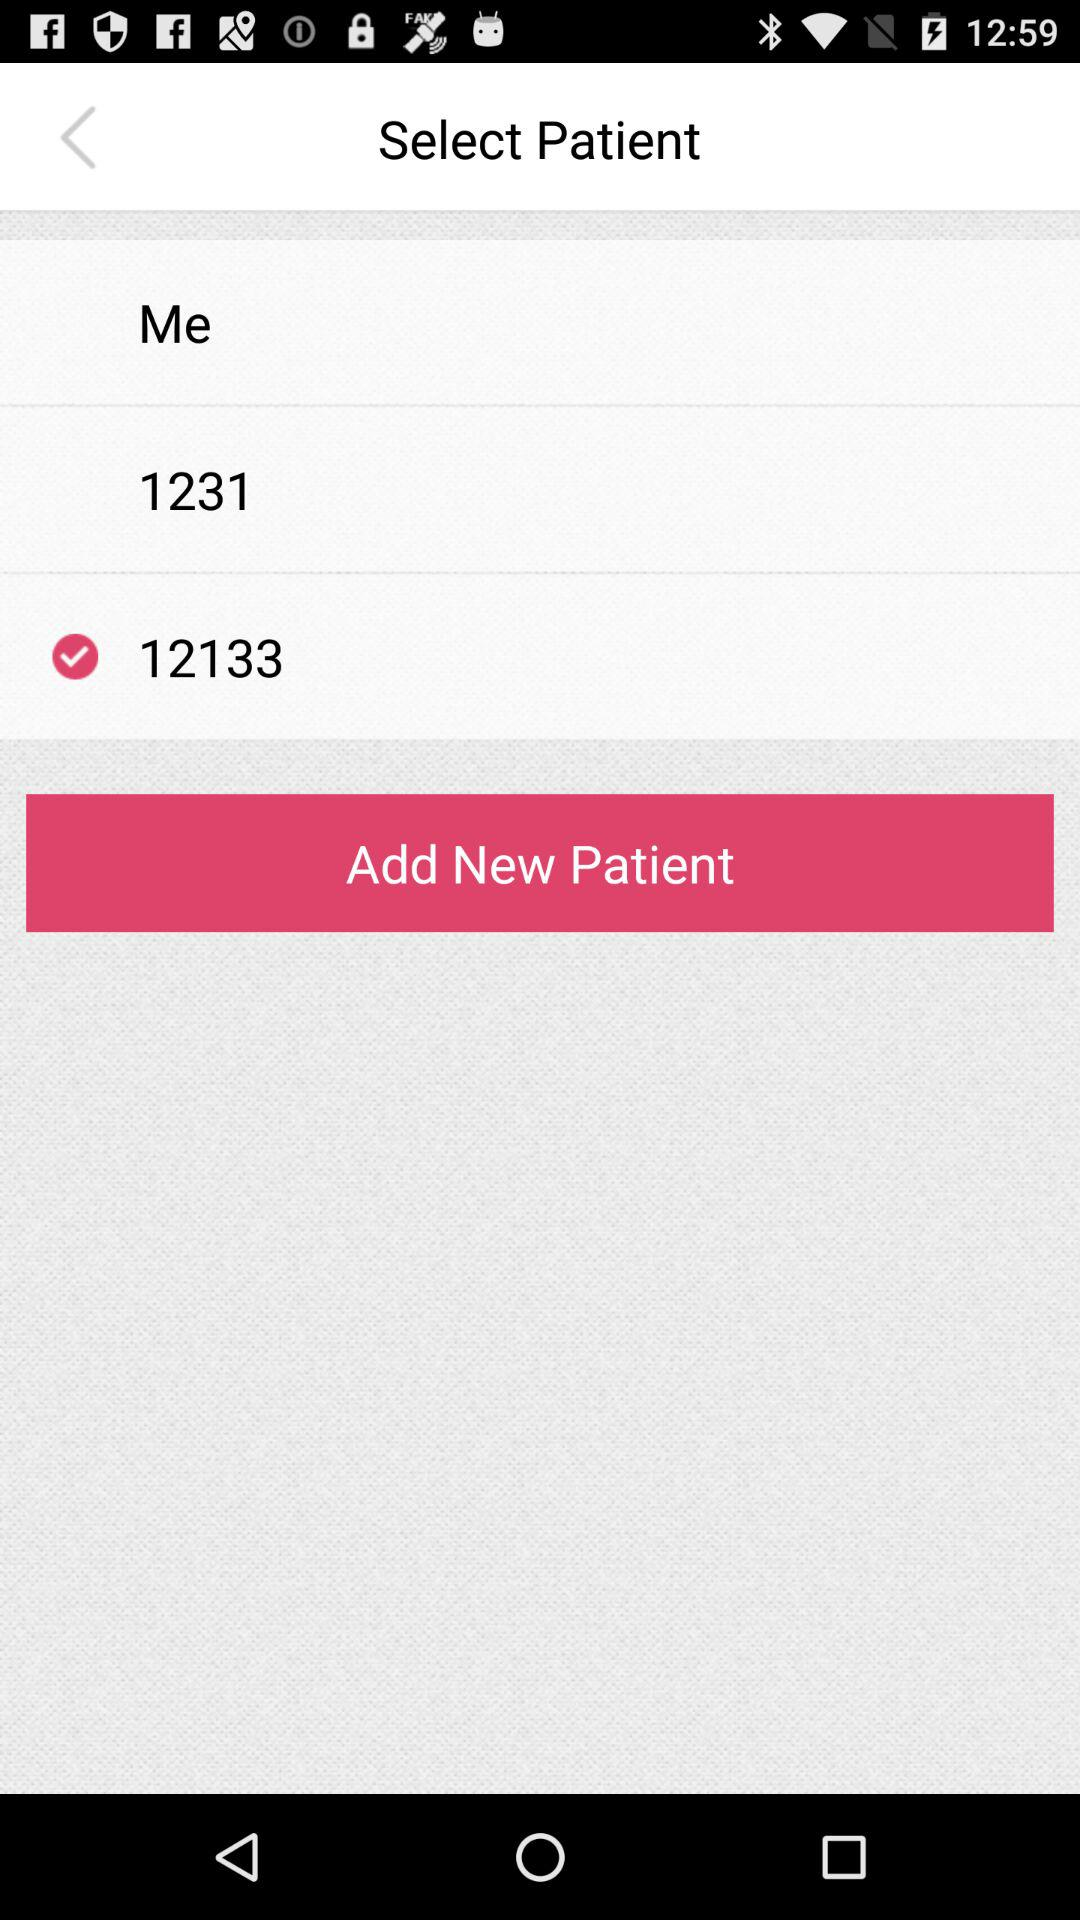What is the selected number? The selected number is 12133. 